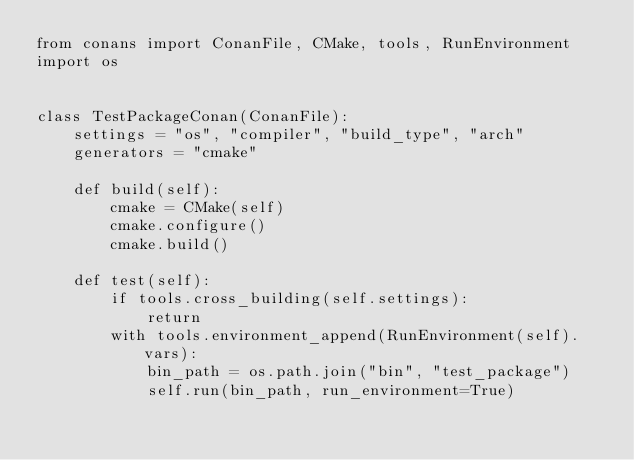<code> <loc_0><loc_0><loc_500><loc_500><_Python_>from conans import ConanFile, CMake, tools, RunEnvironment
import os


class TestPackageConan(ConanFile):
    settings = "os", "compiler", "build_type", "arch"
    generators = "cmake"

    def build(self):
        cmake = CMake(self)
        cmake.configure()
        cmake.build()

    def test(self):
        if tools.cross_building(self.settings):
            return
        with tools.environment_append(RunEnvironment(self).vars):
            bin_path = os.path.join("bin", "test_package")
            self.run(bin_path, run_environment=True)
</code> 